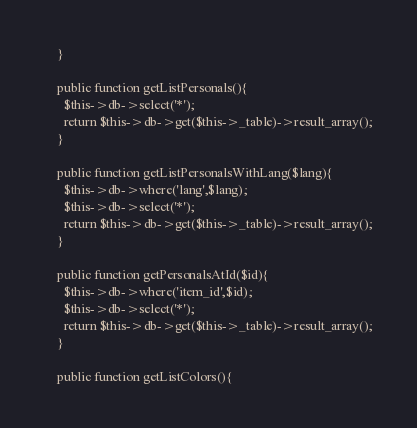Convert code to text. <code><loc_0><loc_0><loc_500><loc_500><_PHP_>    }

    public function getListPersonals(){
      $this->db->select('*');
      return $this->db->get($this->_table)->result_array();
    }

    public function getListPersonalsWithLang($lang){
      $this->db->where('lang',$lang);
      $this->db->select('*');
      return $this->db->get($this->_table)->result_array();
    }

    public function getPersonalsAtId($id){
      $this->db->where('item_id',$id);
      $this->db->select('*');
      return $this->db->get($this->_table)->result_array();
    }

    public function getListColors(){</code> 